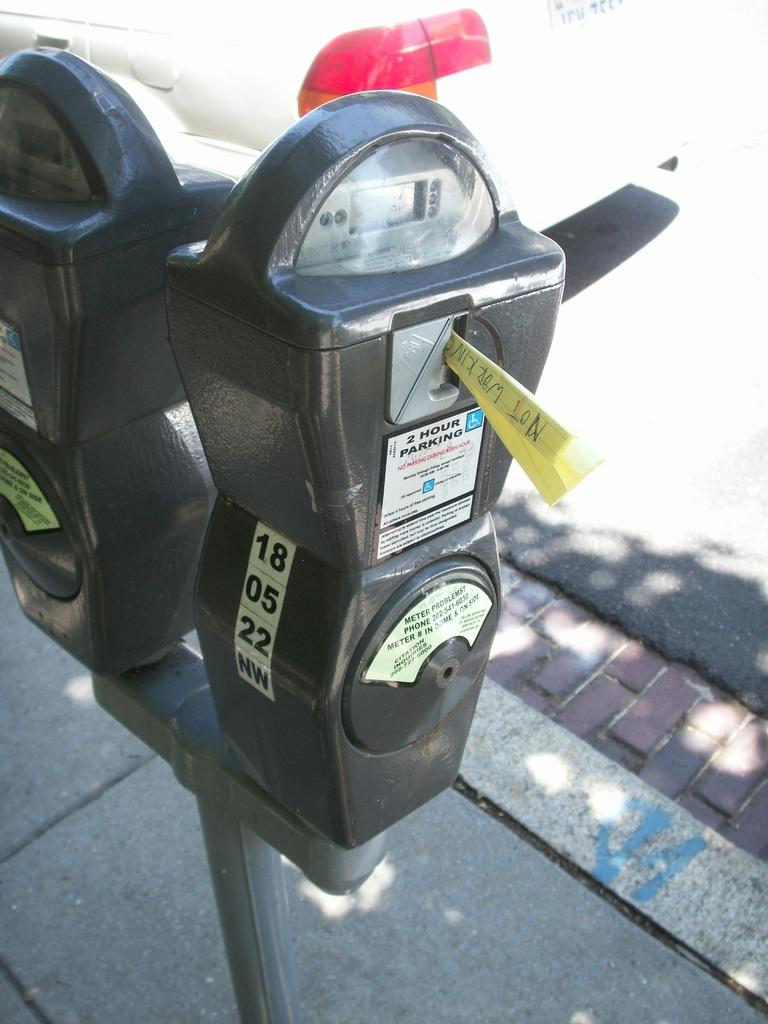<image>
Share a concise interpretation of the image provided. a parking meter with the number 18 on it 